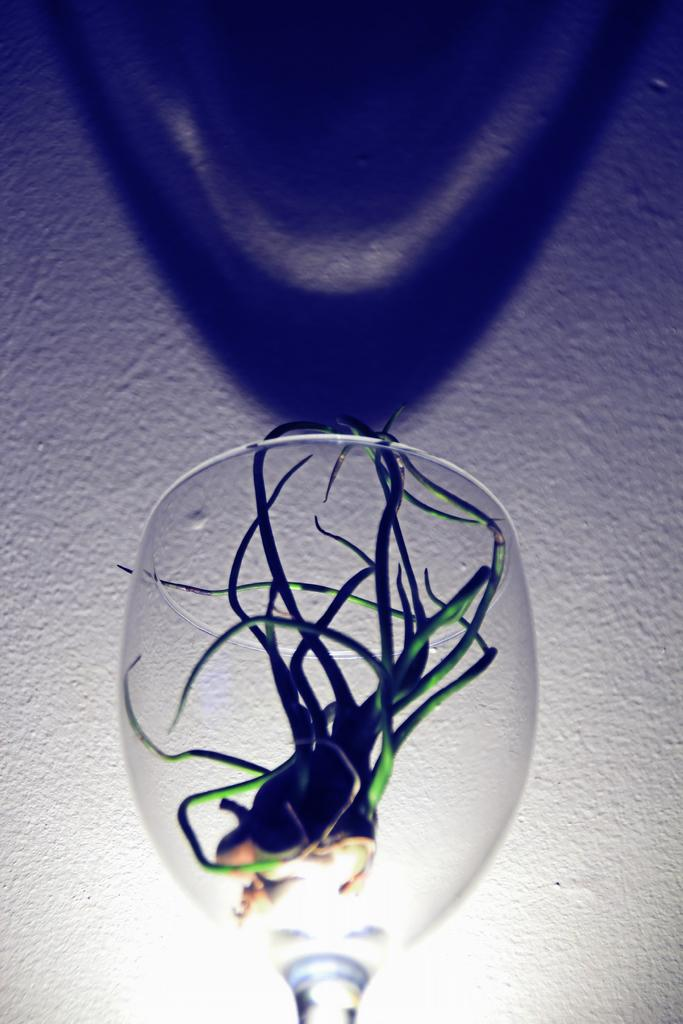What is in the wine glass in the image? There is a plant in the wine glass in the image. What can be seen behind the wine glass? There is a wall behind the wine glass. What is the result of the wine glass's presence on the wall? There is a shadow of the wine glass on the wall. What type of coal is being used to create the shadow on the wall in the image? There is no coal present in the image; the shadow is created by the wine glass and the plant inside it. 